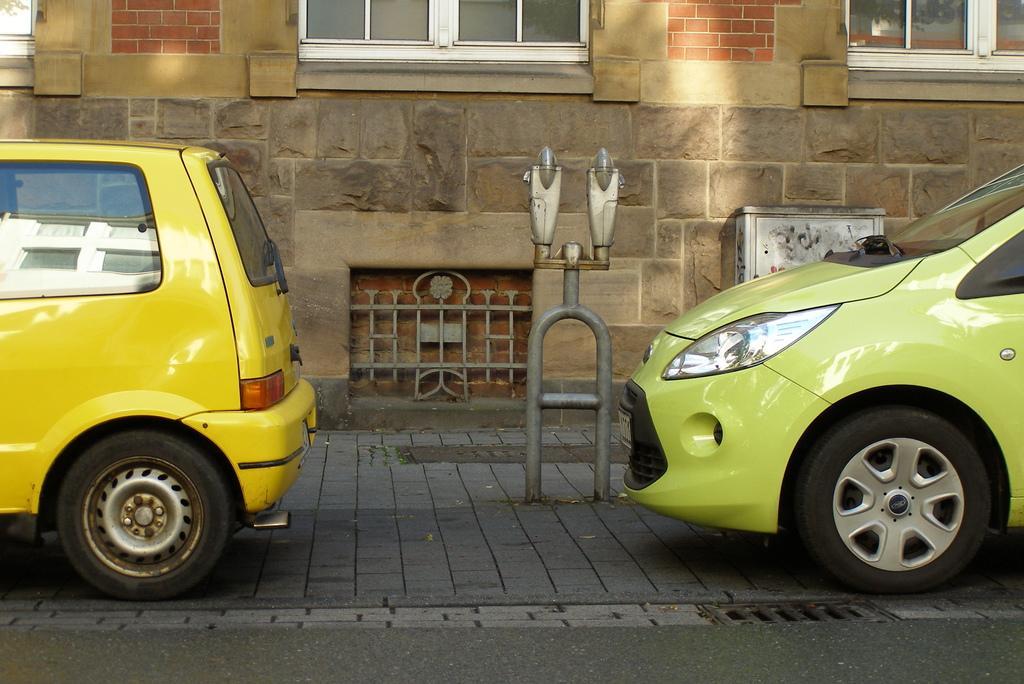Can you describe this image briefly? In this image we can see two vehicles on the road and there is an object which looks like light pole. We can see a building in the background. 